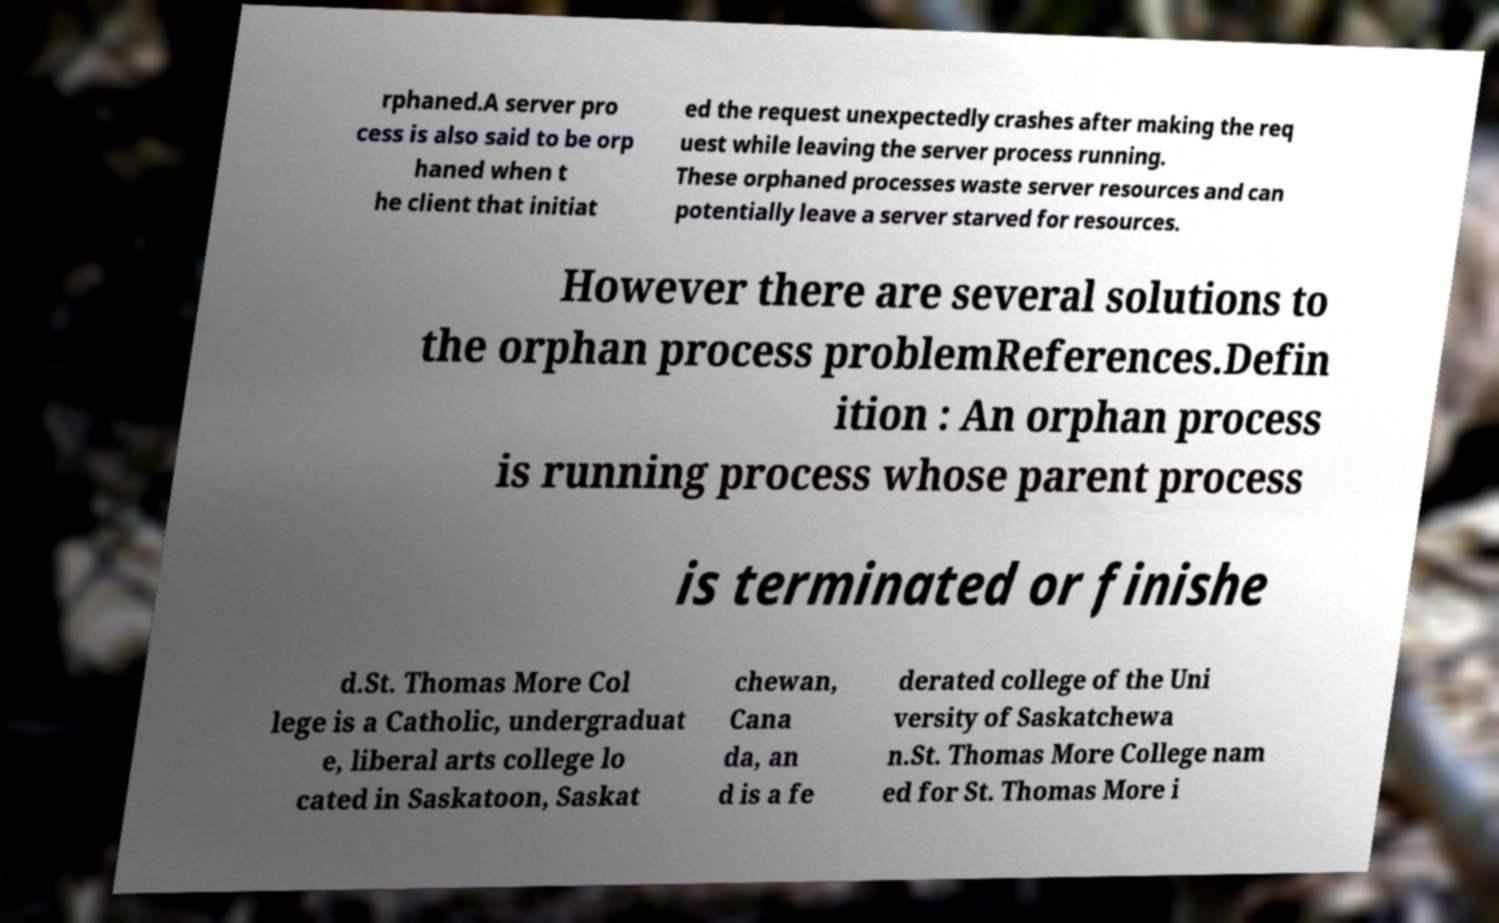Can you accurately transcribe the text from the provided image for me? rphaned.A server pro cess is also said to be orp haned when t he client that initiat ed the request unexpectedly crashes after making the req uest while leaving the server process running. These orphaned processes waste server resources and can potentially leave a server starved for resources. However there are several solutions to the orphan process problemReferences.Defin ition : An orphan process is running process whose parent process is terminated or finishe d.St. Thomas More Col lege is a Catholic, undergraduat e, liberal arts college lo cated in Saskatoon, Saskat chewan, Cana da, an d is a fe derated college of the Uni versity of Saskatchewa n.St. Thomas More College nam ed for St. Thomas More i 